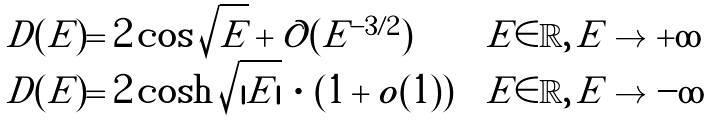<formula> <loc_0><loc_0><loc_500><loc_500>\begin{array} { l l l } D ( E ) = 2 \cos \sqrt { E } + \mathcal { O } ( E ^ { - 3 / 2 } ) & & E \in \mathbb { R } , \, E \to + \infty \\ D ( E ) = 2 \cosh \sqrt { | E | } \, \cdot \, ( 1 + o ( 1 ) ) & & E \in \mathbb { R } , \, E \to - \infty \end{array}</formula> 